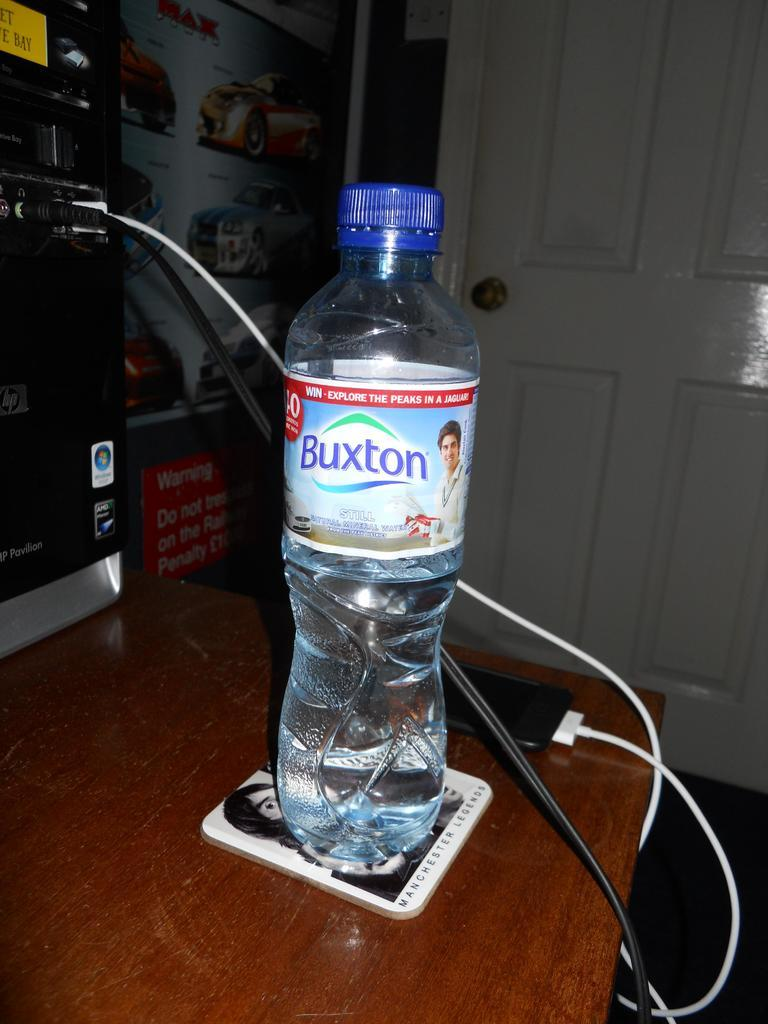What object is placed on the table in the image? There is a water bottle, a cable, and a phone on the table in the image. What can be seen on the left side of the image? There is a car poster on the left side of the image. What is visible in the background of the image? There is a white door in the background of the image. What type of shop is visible in the image? There is no shop present in the image. How many hands are visible in the image? There are no hands visible in the image. 